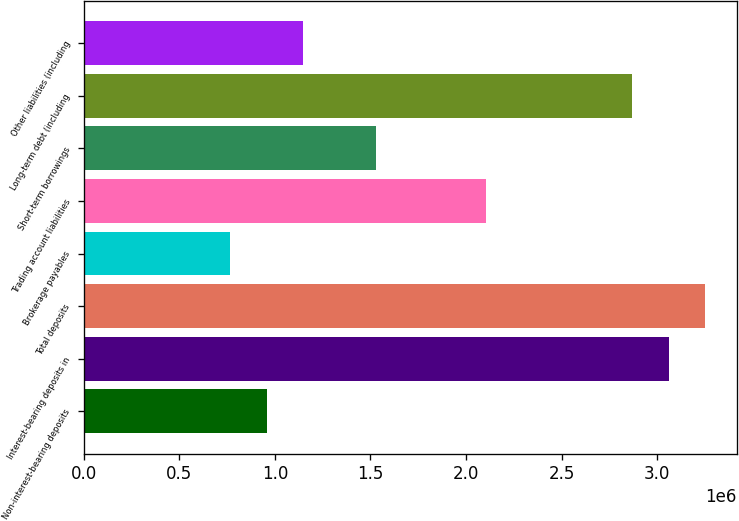<chart> <loc_0><loc_0><loc_500><loc_500><bar_chart><fcel>Non-interest-bearing deposits<fcel>Interest-bearing deposits in<fcel>Total deposits<fcel>Brokerage payables<fcel>Trading account liabilities<fcel>Short-term borrowings<fcel>Long-term debt (including<fcel>Other liabilities (including<nl><fcel>957107<fcel>3.06206e+06<fcel>3.25342e+06<fcel>765748<fcel>2.10526e+06<fcel>1.53118e+06<fcel>2.8707e+06<fcel>1.14847e+06<nl></chart> 